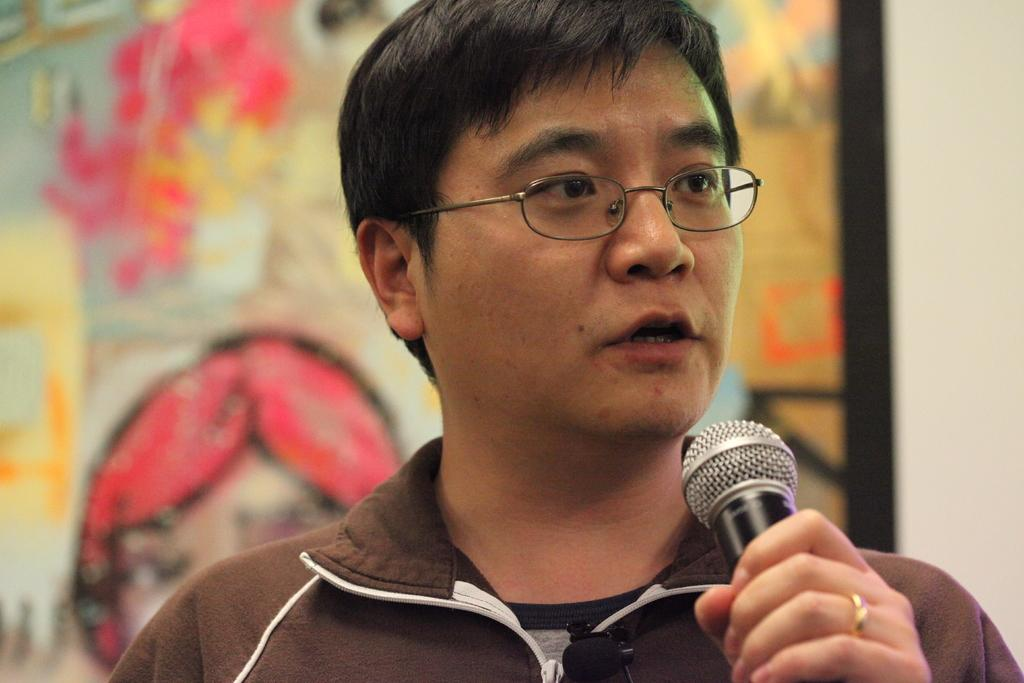What is the main subject of the image? The main subject of the image is a man. What is the man holding in the image? The man is holding a microphone. Can you describe any accessories the man is wearing? The man is wearing glasses. What type of teeth can be seen in the image? There are no teeth visible in the image, as it features a man holding a microphone and wearing glasses. 